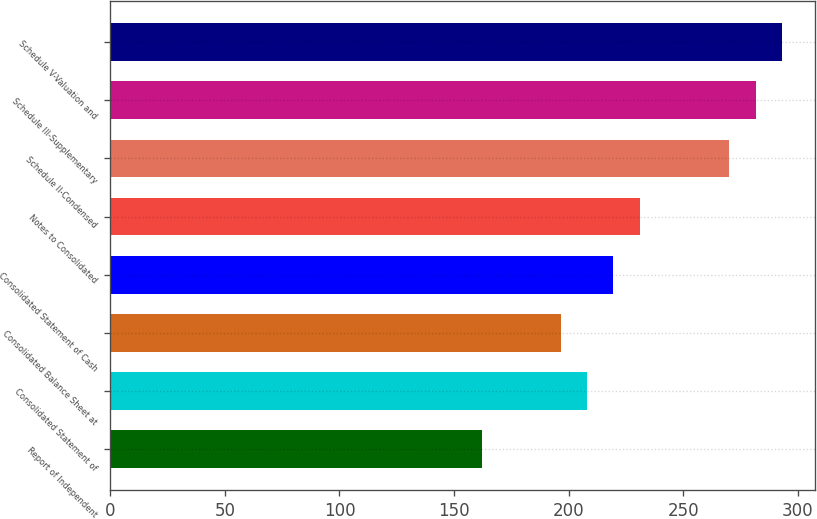Convert chart. <chart><loc_0><loc_0><loc_500><loc_500><bar_chart><fcel>Report of Independent<fcel>Consolidated Statement of<fcel>Consolidated Balance Sheet at<fcel>Consolidated Statement of Cash<fcel>Notes to Consolidated<fcel>Schedule II-Condensed<fcel>Schedule III-Supplementary<fcel>Schedule V-Valuation and<nl><fcel>162<fcel>208<fcel>196.5<fcel>219.5<fcel>231<fcel>270<fcel>281.5<fcel>293<nl></chart> 